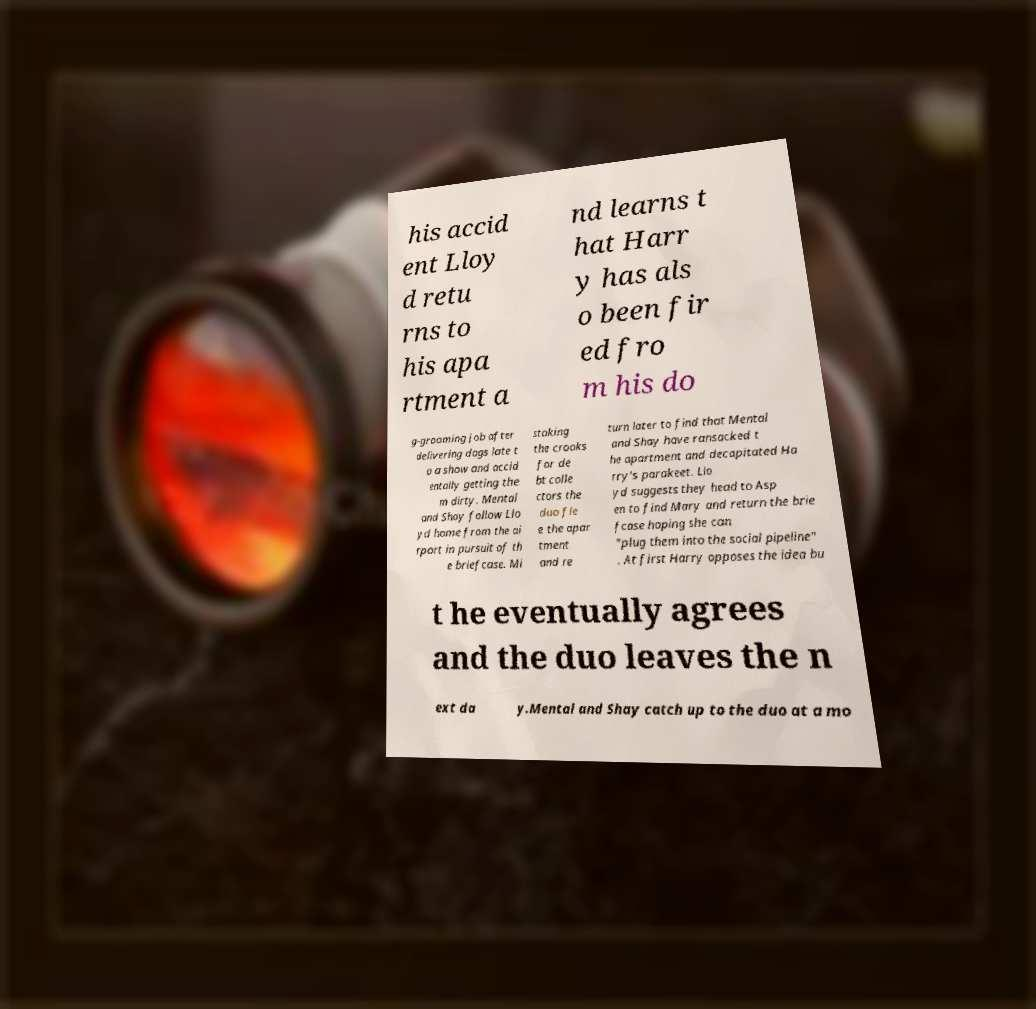There's text embedded in this image that I need extracted. Can you transcribe it verbatim? his accid ent Lloy d retu rns to his apa rtment a nd learns t hat Harr y has als o been fir ed fro m his do g-grooming job after delivering dogs late t o a show and accid entally getting the m dirty. Mental and Shay follow Llo yd home from the ai rport in pursuit of th e briefcase. Mi staking the crooks for de bt colle ctors the duo fle e the apar tment and re turn later to find that Mental and Shay have ransacked t he apartment and decapitated Ha rry's parakeet. Llo yd suggests they head to Asp en to find Mary and return the brie fcase hoping she can "plug them into the social pipeline" . At first Harry opposes the idea bu t he eventually agrees and the duo leaves the n ext da y.Mental and Shay catch up to the duo at a mo 